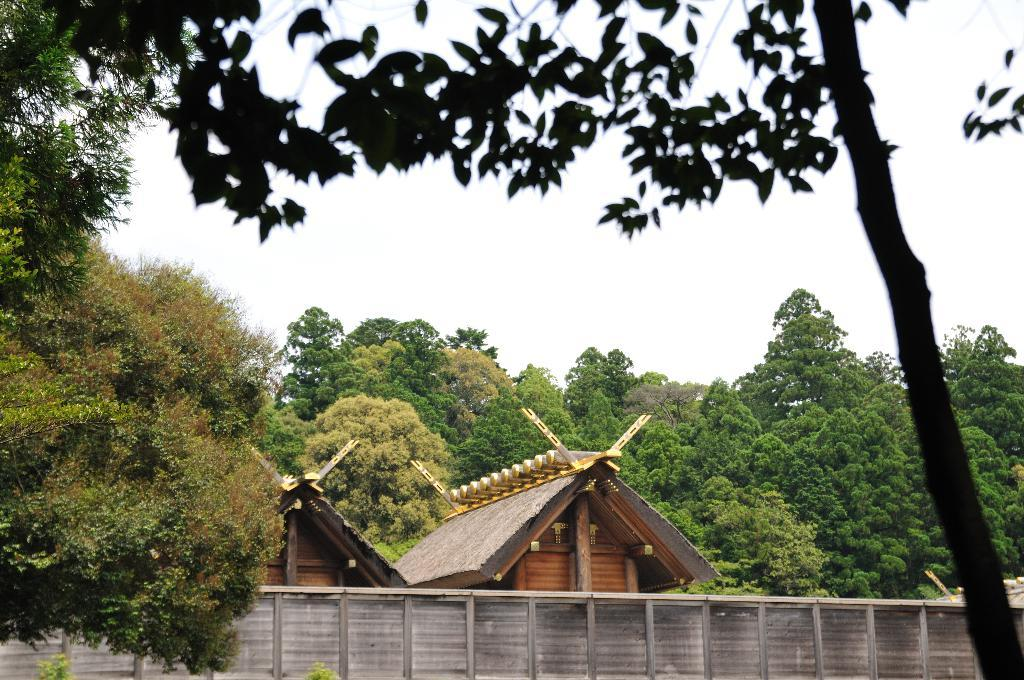What type of structure is present in the image? There is a house in the image. Is there anything separating the house from the surroundings? Yes, the house is behind a fence. What type of natural elements can be seen in the image? There are trees visible in the image. What is visible above the house and trees? The sky is visible in the image. How many trucks are parked next to the house in the image? There are no trucks present in the image. Can you make a comparison between the size of the house and the suit in the image? There is no suit present in the image, so it is not possible to make a comparison. 